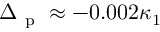<formula> <loc_0><loc_0><loc_500><loc_500>\Delta _ { p } \approx - 0 . 0 0 2 \kappa _ { 1 }</formula> 